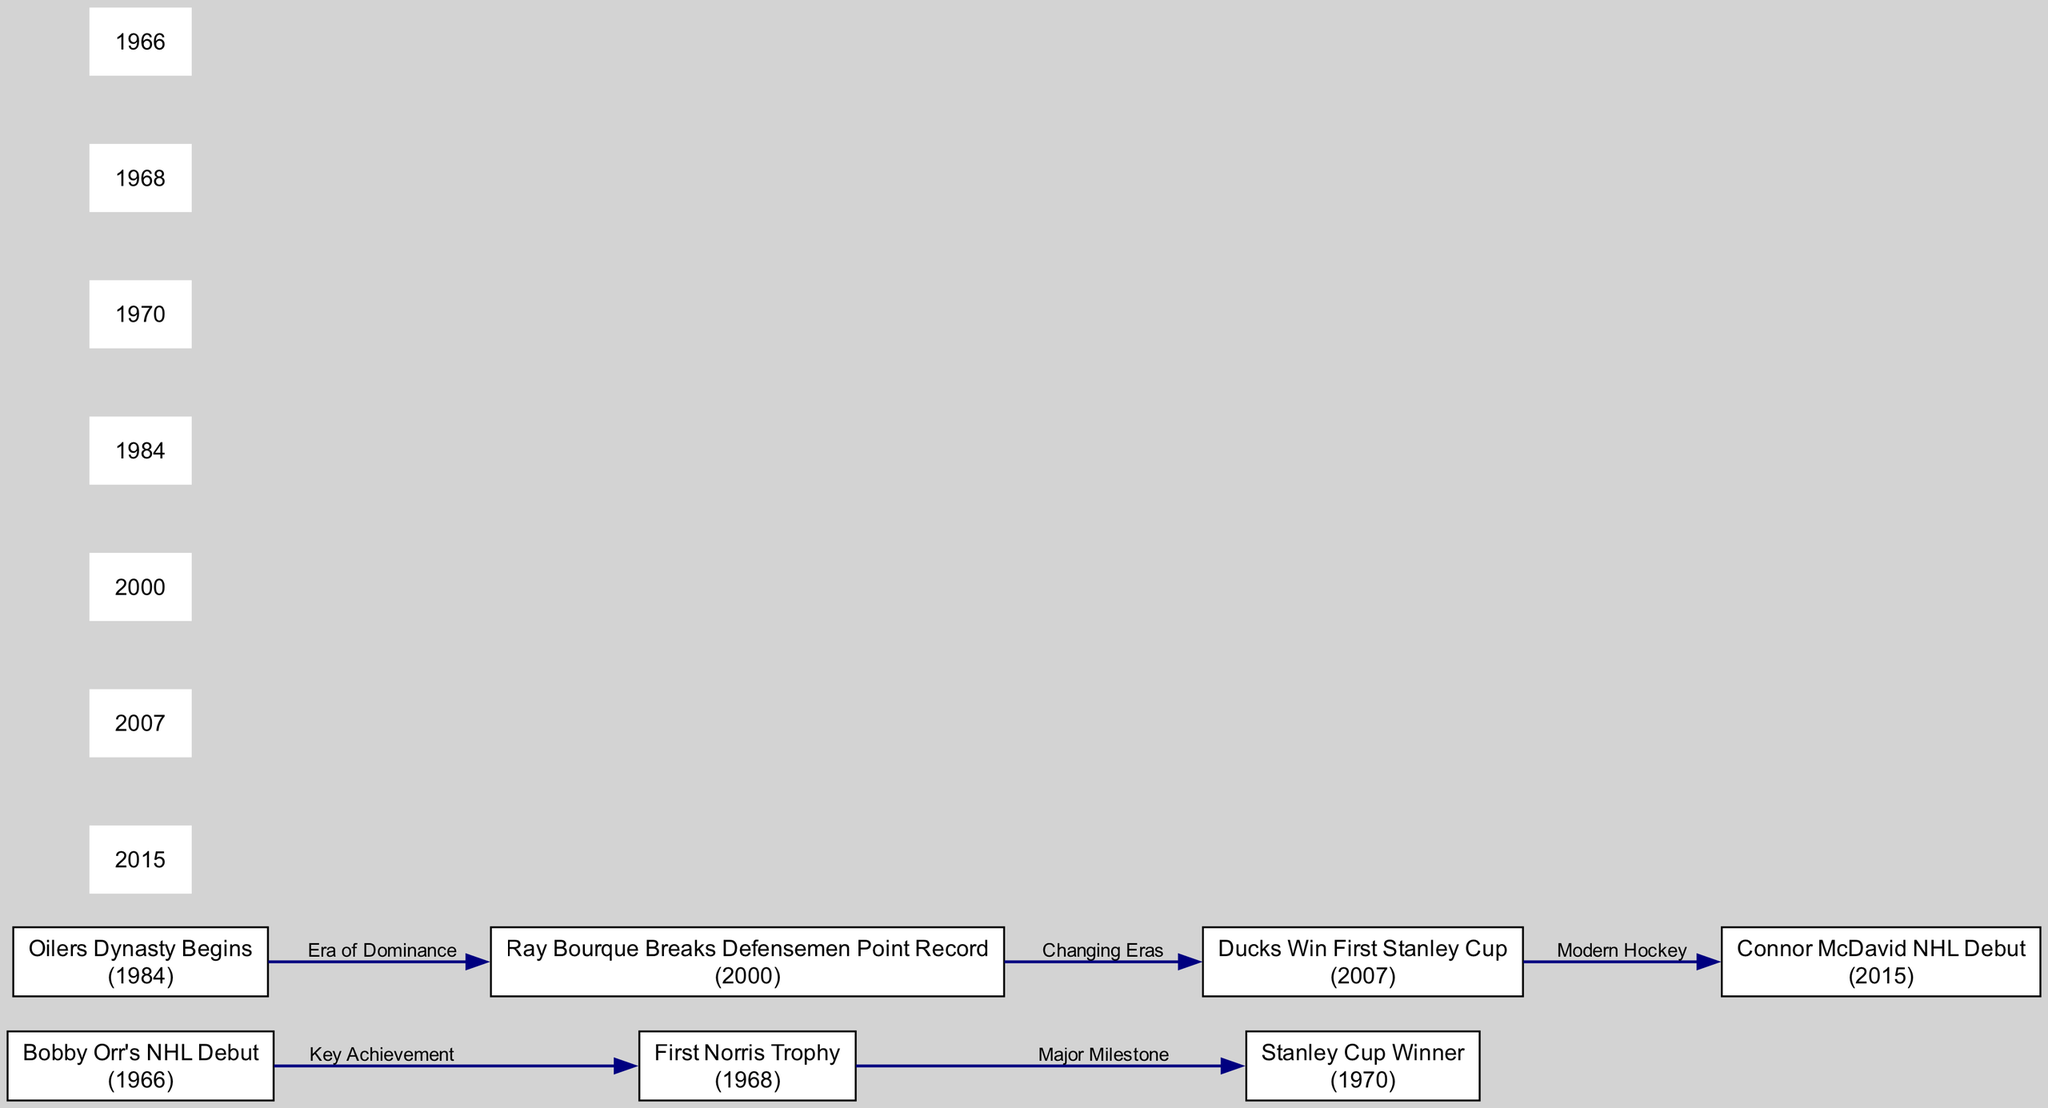What year did Bobby Orr make his NHL debut? The diagram indicates that Bobby Orr's NHL debut is marked by the node labeled "Bobby Orr's NHL Debut" which is dated 1966.
Answer: 1966 How many major milestones are associated with Bobby Orr? By counting the connections (links) associated with Bobby Orr in the diagram, we see that there are two connections: one from his debut to his first Norris Trophy and another from his Norris Trophy to his Stanley Cup win.
Answer: 2 What significant event occurred in 1984? The diagram shows that in 1984, the "Oilers Dynasty Begins," which is a milestone event in hockey history.
Answer: Oilers Dynasty Begins What was the key milestone for Ray Bourque in 2000? The diagram highlights that in 2000, Ray Bourque broke the defensemen point record, indicating his major achievement that year.
Answer: Ray Bourque Breaks Defensemen Point Record What connects the Ducks' first Stanley Cup to Connor McDavid's debut? The diagram illustrates that the Ducks winning their first Stanley Cup in 2007 is linked to McDavid's NHL debut in 2015 through the label "Modern Hockey." This implies a timeline transition in hockey history.
Answer: Modern Hockey Which node represents a transition from an era of dominance? The diagram indicates that the transition from the "Oilers Dynasty" to the record set by Ray Bourque marks an era of dominance, represented by the link labeled "Era of Dominance."
Answer: Era of Dominance What were the consecutive achievements of Bobby Orr as depicted in the diagram? The diagram shows a sequence starting from Bobby Orr's debut in 1966, followed by his first Norris Trophy in 1968, and culminating with his Stanley Cup win in 1970. These nodes connect sequentially, illustrating his key achievements.
Answer: NHL Debut, First Norris Trophy, Stanley Cup Winner What milestone represents a transition to a changing era? According to the diagram, the link from the moment Ray Bourque broke the point record in 2000 to the Ducks winning their first Stanley Cup in 2007 is labeled "Changing Eras," indicating a significant transition.
Answer: Changing Eras How many total nodes are displayed in the diagram? By counting all the nodes present in the diagram, we find there are six notable achievements or milestones featured in the timeline, indicating the focus on significant moments in the careers of these defensemen.
Answer: 6 